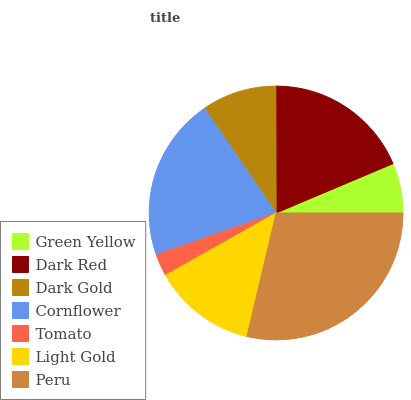Is Tomato the minimum?
Answer yes or no. Yes. Is Peru the maximum?
Answer yes or no. Yes. Is Dark Red the minimum?
Answer yes or no. No. Is Dark Red the maximum?
Answer yes or no. No. Is Dark Red greater than Green Yellow?
Answer yes or no. Yes. Is Green Yellow less than Dark Red?
Answer yes or no. Yes. Is Green Yellow greater than Dark Red?
Answer yes or no. No. Is Dark Red less than Green Yellow?
Answer yes or no. No. Is Light Gold the high median?
Answer yes or no. Yes. Is Light Gold the low median?
Answer yes or no. Yes. Is Green Yellow the high median?
Answer yes or no. No. Is Green Yellow the low median?
Answer yes or no. No. 